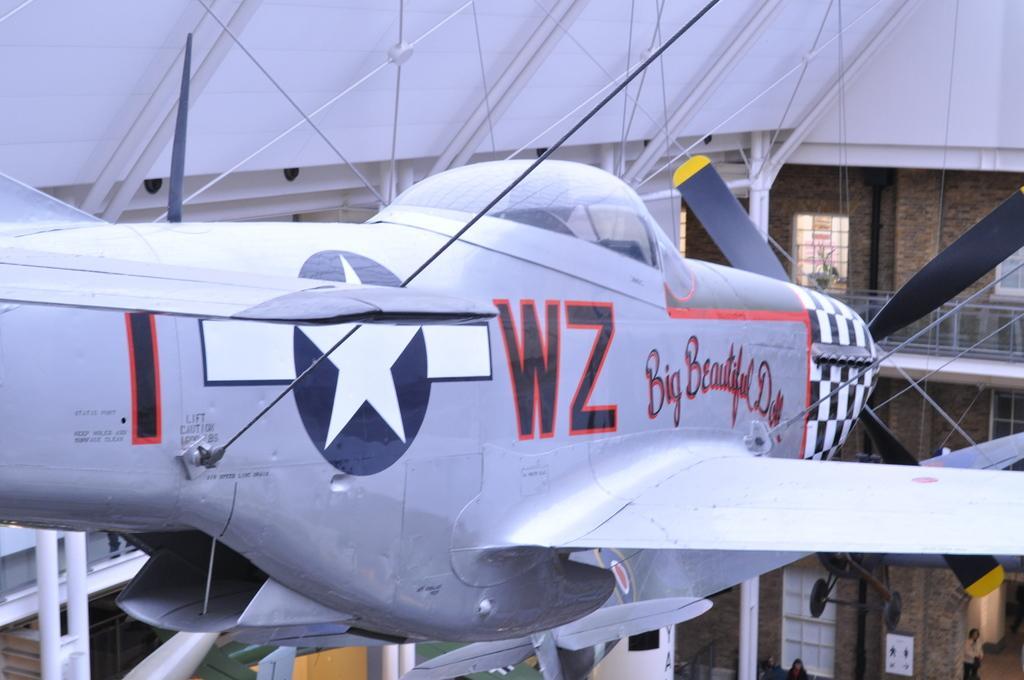In one or two sentences, can you explain what this image depicts? In this image we can see an aircraft. We can also see some rods and also the building with the windows. At the bottom we can see the people. 